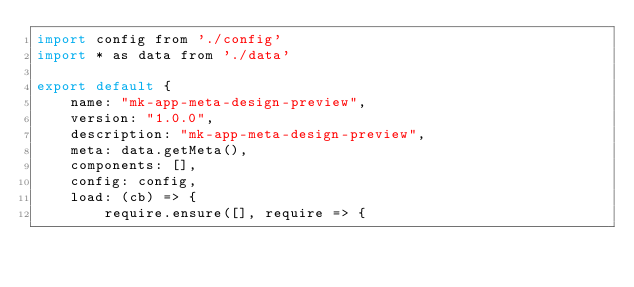Convert code to text. <code><loc_0><loc_0><loc_500><loc_500><_JavaScript_>import config from './config'
import * as data from './data'

export default {
	name: "mk-app-meta-design-preview",
	version: "1.0.0",
	description: "mk-app-meta-design-preview",
	meta: data.getMeta(),
	components: [],
	config: config,
	load: (cb) => {
		require.ensure([], require => {</code> 